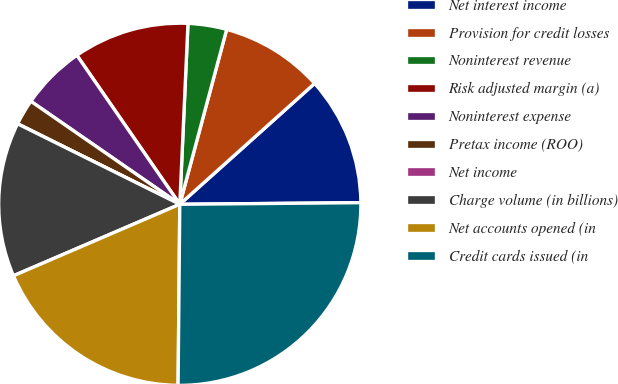Convert chart to OTSL. <chart><loc_0><loc_0><loc_500><loc_500><pie_chart><fcel>Net interest income<fcel>Provision for credit losses<fcel>Noninterest revenue<fcel>Risk adjusted margin (a)<fcel>Noninterest expense<fcel>Pretax income (ROO)<fcel>Net income<fcel>Charge volume (in billions)<fcel>Net accounts opened (in<fcel>Credit cards issued (in<nl><fcel>11.49%<fcel>9.2%<fcel>3.45%<fcel>10.34%<fcel>5.75%<fcel>2.3%<fcel>0.0%<fcel>13.79%<fcel>18.39%<fcel>25.29%<nl></chart> 